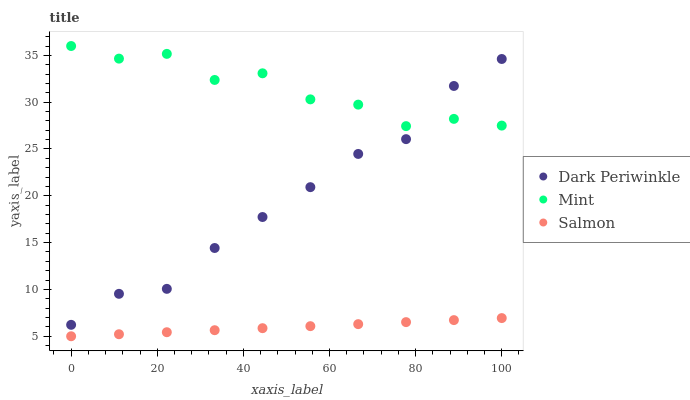Does Salmon have the minimum area under the curve?
Answer yes or no. Yes. Does Mint have the maximum area under the curve?
Answer yes or no. Yes. Does Dark Periwinkle have the minimum area under the curve?
Answer yes or no. No. Does Dark Periwinkle have the maximum area under the curve?
Answer yes or no. No. Is Salmon the smoothest?
Answer yes or no. Yes. Is Mint the roughest?
Answer yes or no. Yes. Is Dark Periwinkle the smoothest?
Answer yes or no. No. Is Dark Periwinkle the roughest?
Answer yes or no. No. Does Salmon have the lowest value?
Answer yes or no. Yes. Does Dark Periwinkle have the lowest value?
Answer yes or no. No. Does Mint have the highest value?
Answer yes or no. Yes. Does Dark Periwinkle have the highest value?
Answer yes or no. No. Is Salmon less than Mint?
Answer yes or no. Yes. Is Mint greater than Salmon?
Answer yes or no. Yes. Does Dark Periwinkle intersect Mint?
Answer yes or no. Yes. Is Dark Periwinkle less than Mint?
Answer yes or no. No. Is Dark Periwinkle greater than Mint?
Answer yes or no. No. Does Salmon intersect Mint?
Answer yes or no. No. 